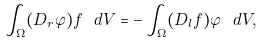<formula> <loc_0><loc_0><loc_500><loc_500>\int _ { \Omega } ( D _ { r } \varphi ) f \ d V = - \int _ { \Omega } ( D _ { l } f ) \varphi \ d V ,</formula> 